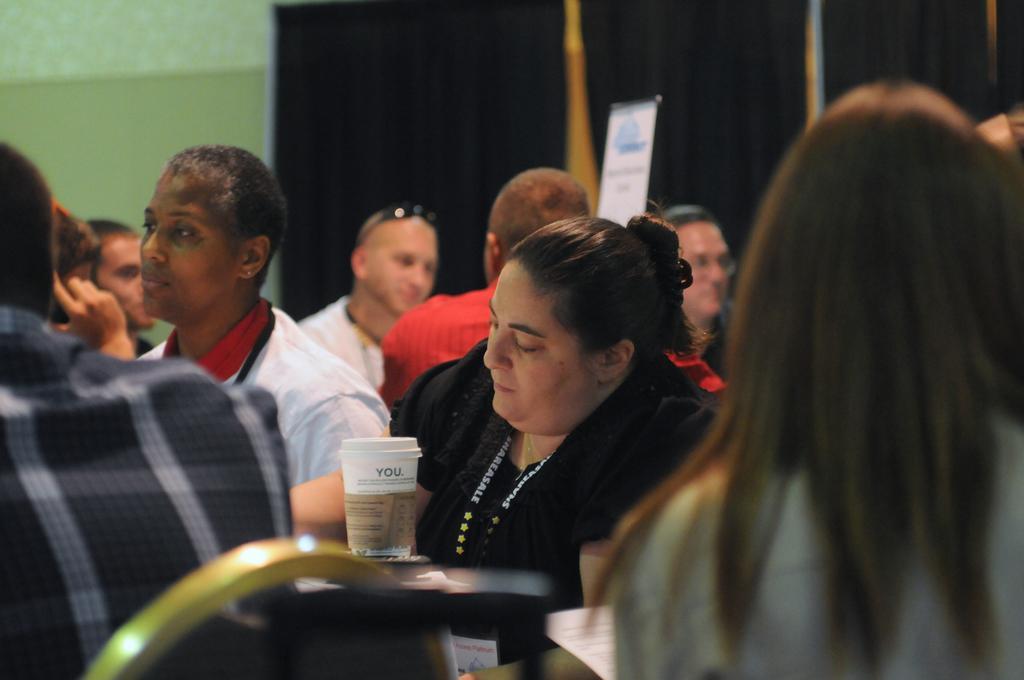Please provide a concise description of this image. In the image there are many people sitting around the tables,on one of the table there is a coffee cup and behind the people there is a black curtain and in front of the curtain there is a small notice board. 